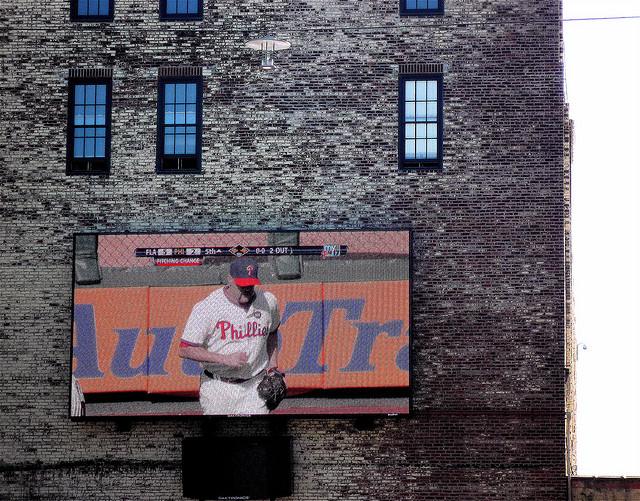Is this flat screen on the side of a building?
Short answer required. Yes. Do people use this object to travel with?
Answer briefly. No. What sport is being played?
Quick response, please. Baseball. What team is playing?
Write a very short answer. Phillies. 